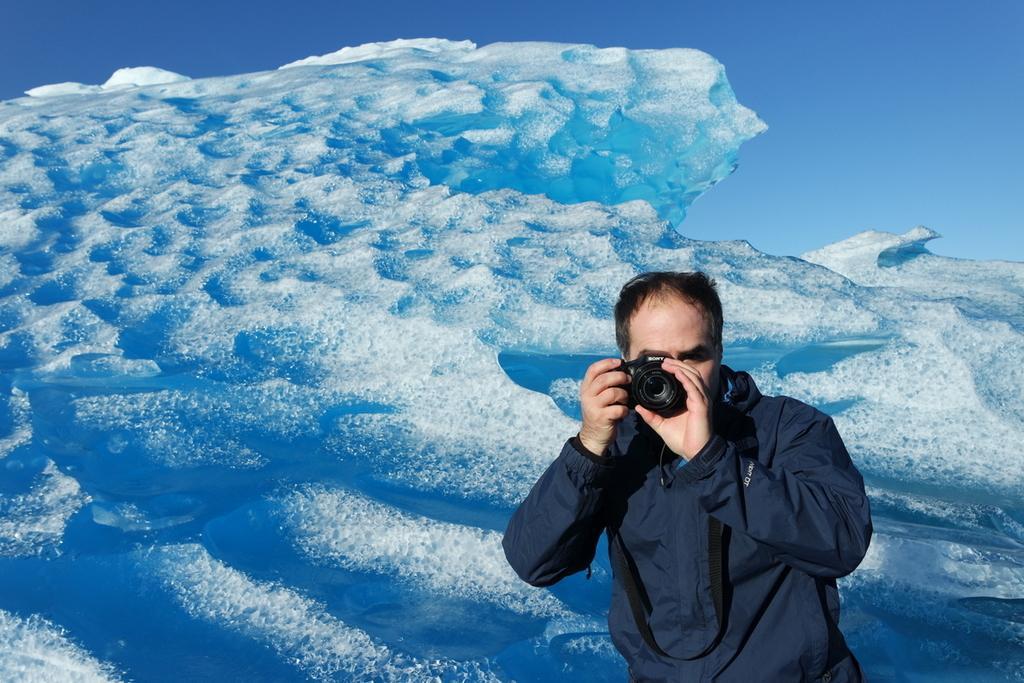Please provide a concise description of this image. This is a picture of a man in a blue jacket, the man holding a camera. The background of the man is a water. 